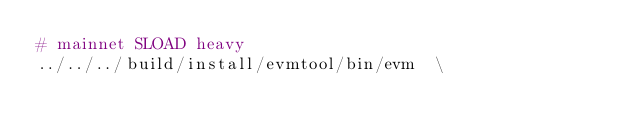<code> <loc_0><loc_0><loc_500><loc_500><_Bash_># mainnet SLOAD heavy
../../../build/install/evmtool/bin/evm  \</code> 